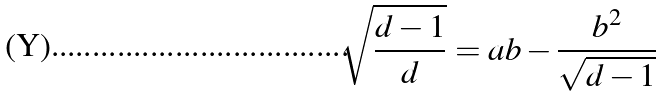<formula> <loc_0><loc_0><loc_500><loc_500>\sqrt { \frac { d - 1 } { d } } = a b - \frac { b ^ { 2 } } { \sqrt { d - 1 } }</formula> 